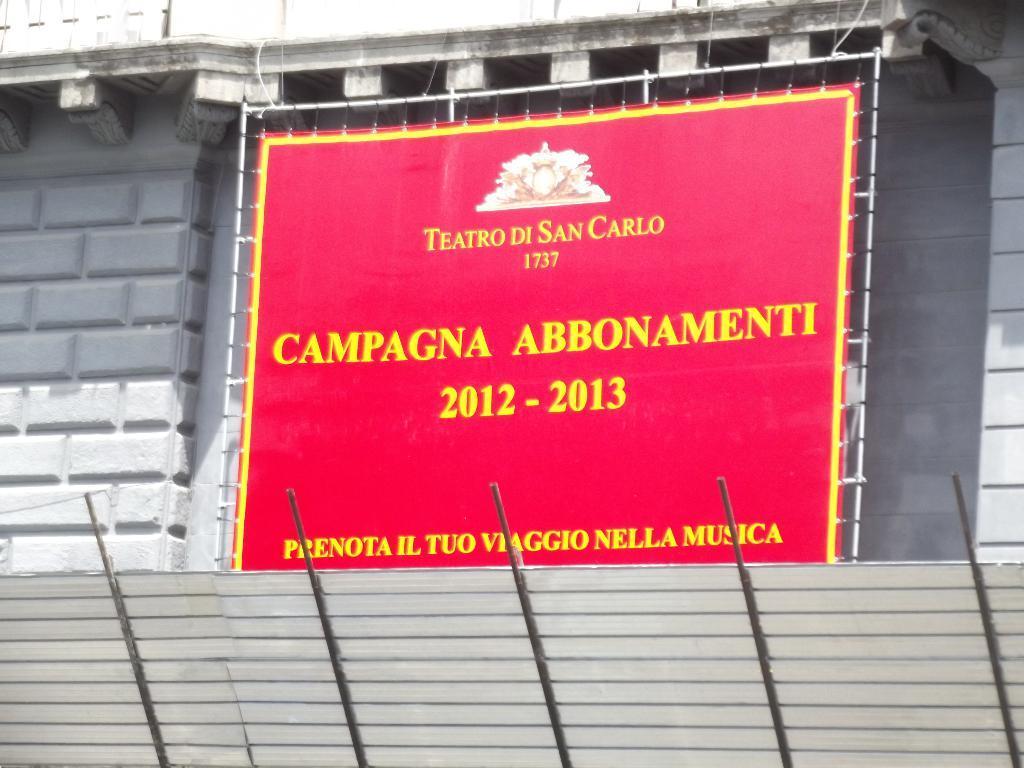Can you describe this image briefly? In this image we can see a banner with some text and there is a building in the background and we can see some metal rods at the bottom of the image. 